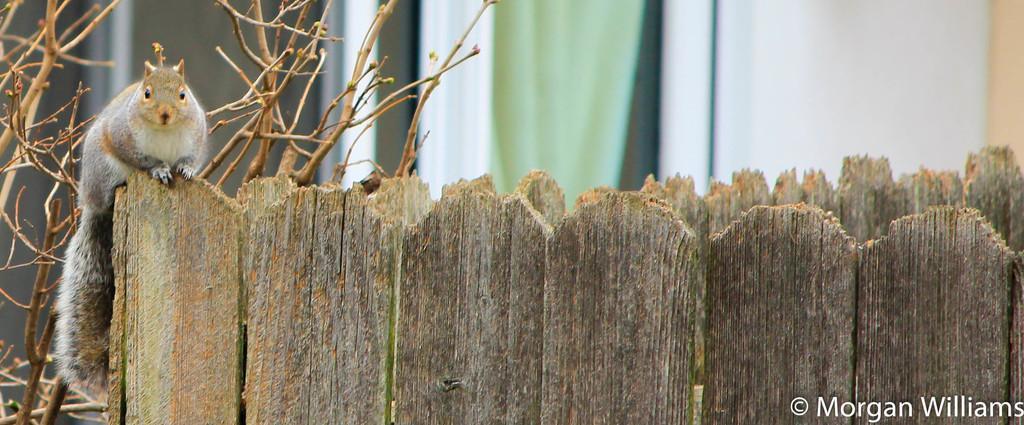Describe this image in one or two sentences. In this image we can see a squirrel sitting on a wooden fence and in the background there are some plants and a wall. 